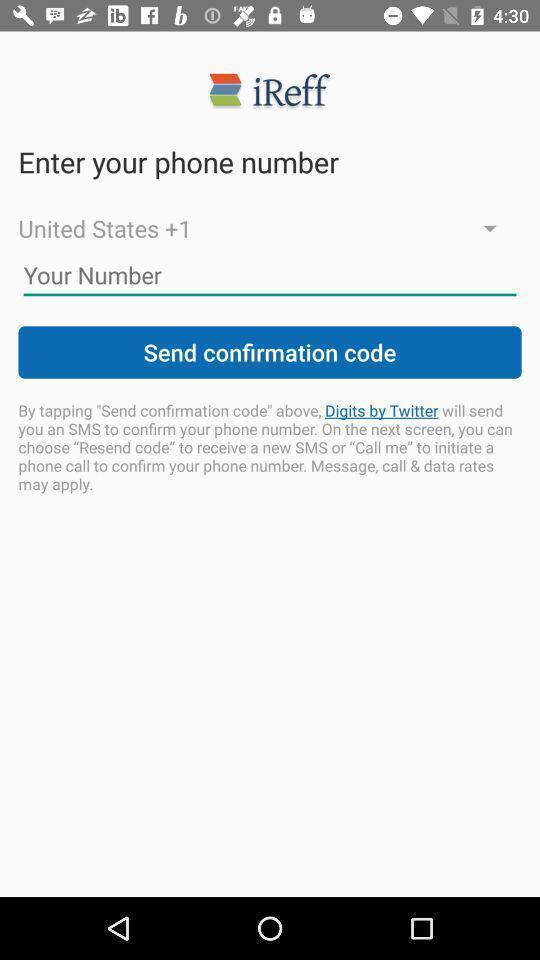Describe the key features of this screenshot. Page showing to enter phone number. 